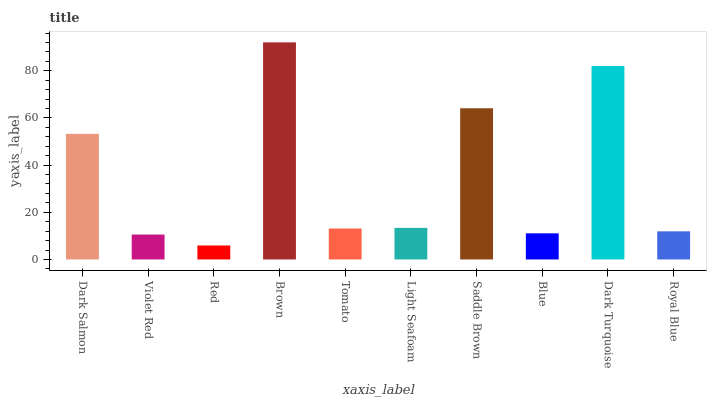Is Red the minimum?
Answer yes or no. Yes. Is Brown the maximum?
Answer yes or no. Yes. Is Violet Red the minimum?
Answer yes or no. No. Is Violet Red the maximum?
Answer yes or no. No. Is Dark Salmon greater than Violet Red?
Answer yes or no. Yes. Is Violet Red less than Dark Salmon?
Answer yes or no. Yes. Is Violet Red greater than Dark Salmon?
Answer yes or no. No. Is Dark Salmon less than Violet Red?
Answer yes or no. No. Is Light Seafoam the high median?
Answer yes or no. Yes. Is Tomato the low median?
Answer yes or no. Yes. Is Dark Turquoise the high median?
Answer yes or no. No. Is Light Seafoam the low median?
Answer yes or no. No. 